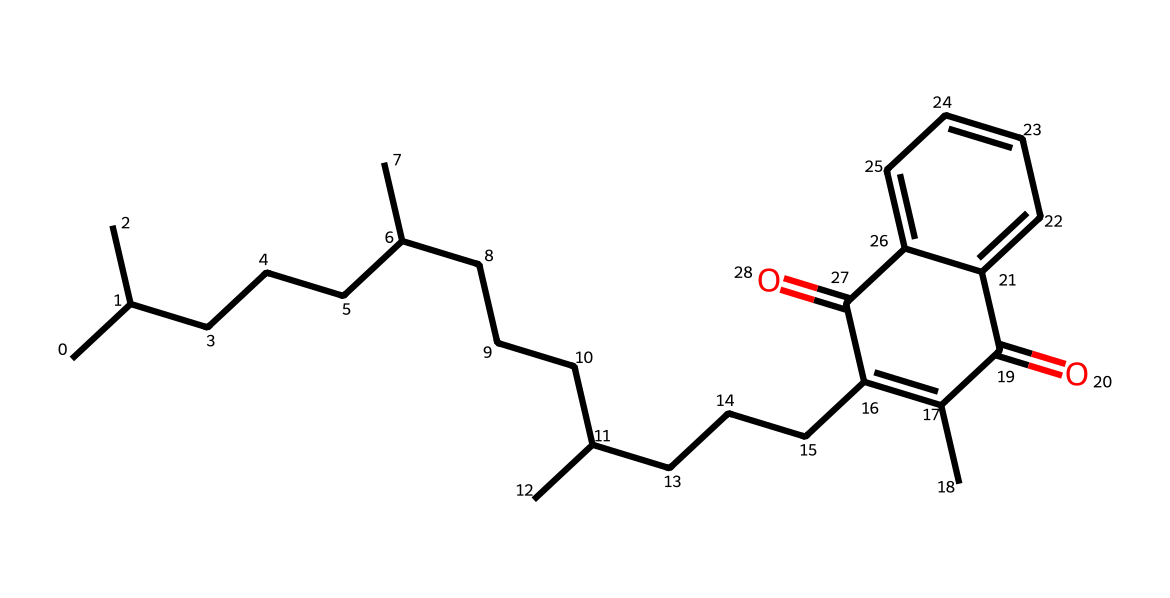What is the name of this vitamin? The provided SMILES representation corresponds to Vitamin K. The presence of a long carbon chain and the particular functional groups indicate its classification.
Answer: Vitamin K How many carbon atoms are present in this structure? By analyzing the chemical structure from the SMILES, I count a total of 27 carbon atoms (denoted by each 'C' in the chain and connected structures).
Answer: 27 What is the significance of this vitamin for bone health? Vitamin K plays a crucial role in bone health by assisting in the regulation of calcium in bones and blood. Its specific molecular structure is vital for its function.
Answer: Bone health Does this vitamin contain any double bonds? Yes, the presence of the '=' sign in the SMILES indicates double bonds; there are multiple in this molecule, which contribute to its structure.
Answer: Yes What functional group is present in this molecule? The presence of the 'C(=O)' part of the SMILES indicates a ketone functional group, which is an essential feature for Vitamin K’s biological function.
Answer: Ketone What type of chemical does this structure represent? This structure represents a lipid-soluble vitamin due to its hydrophobic carbon chain and presence of long carbon atoms typical of fat-soluble vitamins such as K.
Answer: Fat-soluble vitamin 